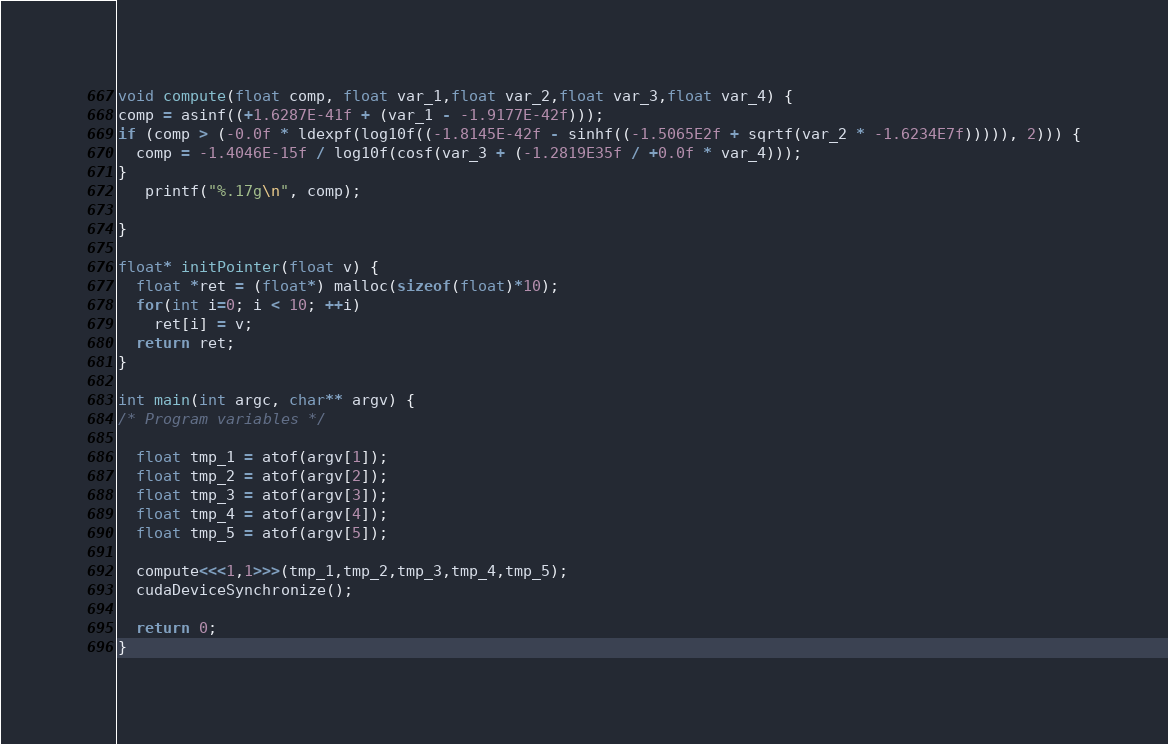<code> <loc_0><loc_0><loc_500><loc_500><_Cuda_>void compute(float comp, float var_1,float var_2,float var_3,float var_4) {
comp = asinf((+1.6287E-41f + (var_1 - -1.9177E-42f)));
if (comp > (-0.0f * ldexpf(log10f((-1.8145E-42f - sinhf((-1.5065E2f + sqrtf(var_2 * -1.6234E7f))))), 2))) {
  comp = -1.4046E-15f / log10f(cosf(var_3 + (-1.2819E35f / +0.0f * var_4)));
}
   printf("%.17g\n", comp);

}

float* initPointer(float v) {
  float *ret = (float*) malloc(sizeof(float)*10);
  for(int i=0; i < 10; ++i)
    ret[i] = v;
  return ret;
}

int main(int argc, char** argv) {
/* Program variables */

  float tmp_1 = atof(argv[1]);
  float tmp_2 = atof(argv[2]);
  float tmp_3 = atof(argv[3]);
  float tmp_4 = atof(argv[4]);
  float tmp_5 = atof(argv[5]);

  compute<<<1,1>>>(tmp_1,tmp_2,tmp_3,tmp_4,tmp_5);
  cudaDeviceSynchronize();

  return 0;
}
</code> 